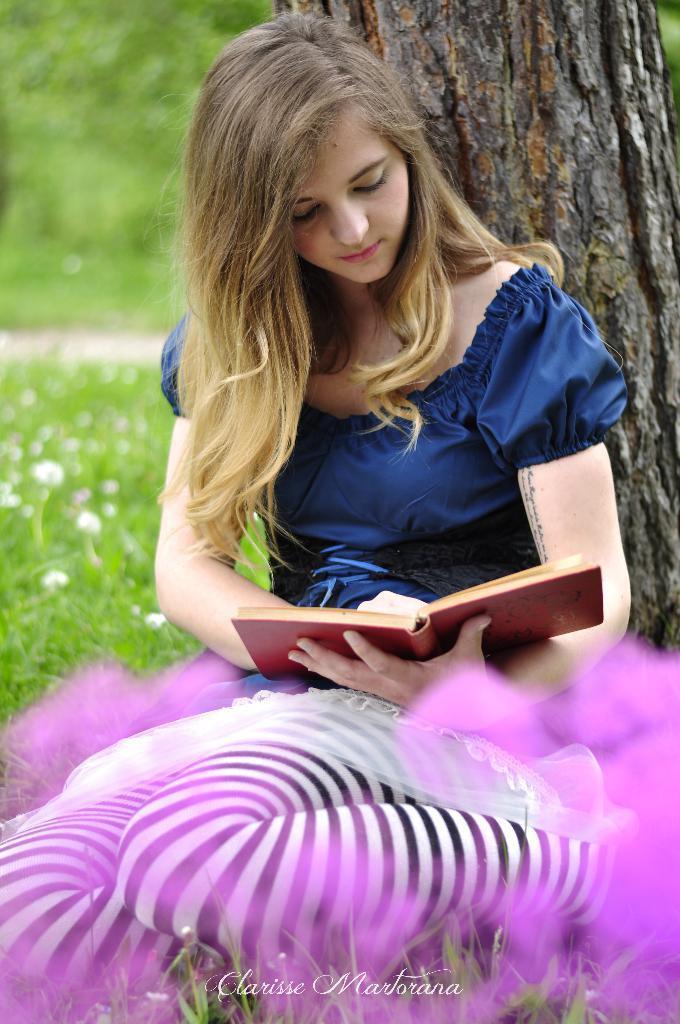Describe this image in one or two sentences. In this image we can see a lady sitting and holding a book. In the background there is a tree. At the bottom there is grass and we can see flowers. 